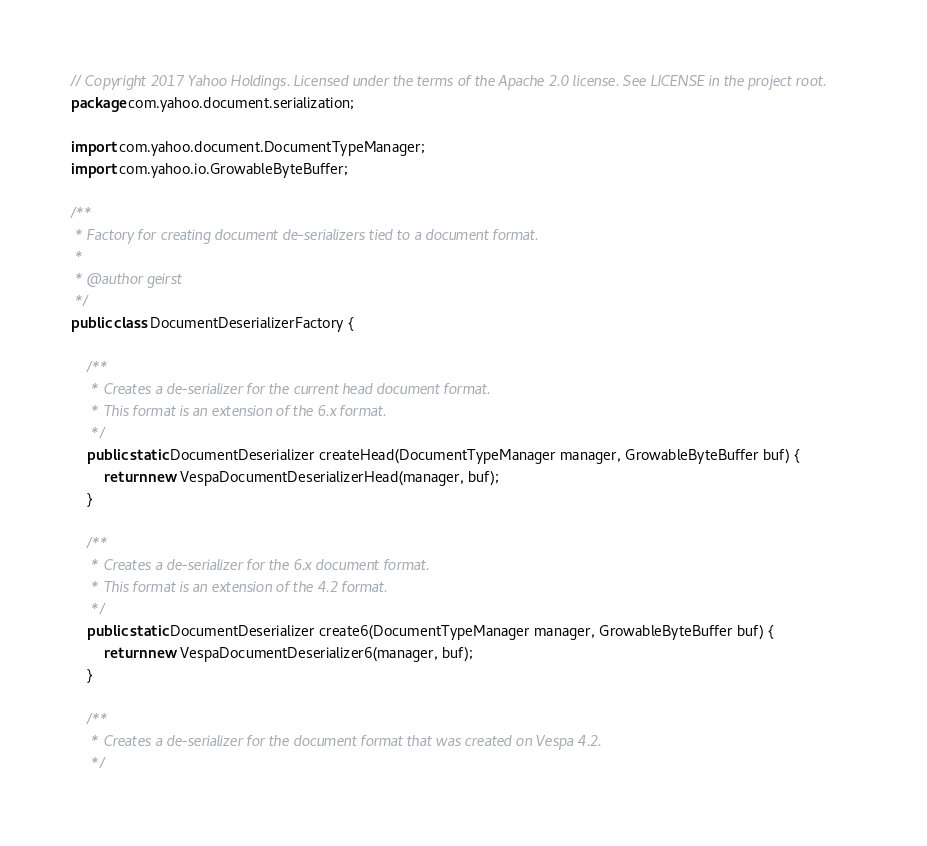<code> <loc_0><loc_0><loc_500><loc_500><_Java_>// Copyright 2017 Yahoo Holdings. Licensed under the terms of the Apache 2.0 license. See LICENSE in the project root.
package com.yahoo.document.serialization;

import com.yahoo.document.DocumentTypeManager;
import com.yahoo.io.GrowableByteBuffer;

/**
 * Factory for creating document de-serializers tied to a document format.
 *
 * @author geirst
 */
public class DocumentDeserializerFactory {

    /**
     * Creates a de-serializer for the current head document format.
     * This format is an extension of the 6.x format.
     */
    public static DocumentDeserializer createHead(DocumentTypeManager manager, GrowableByteBuffer buf) {
        return new VespaDocumentDeserializerHead(manager, buf);
    }

    /**
     * Creates a de-serializer for the 6.x document format.
     * This format is an extension of the 4.2 format.
     */
    public static DocumentDeserializer create6(DocumentTypeManager manager, GrowableByteBuffer buf) {
        return new VespaDocumentDeserializer6(manager, buf);
    }

    /**
     * Creates a de-serializer for the document format that was created on Vespa 4.2.
     */</code> 